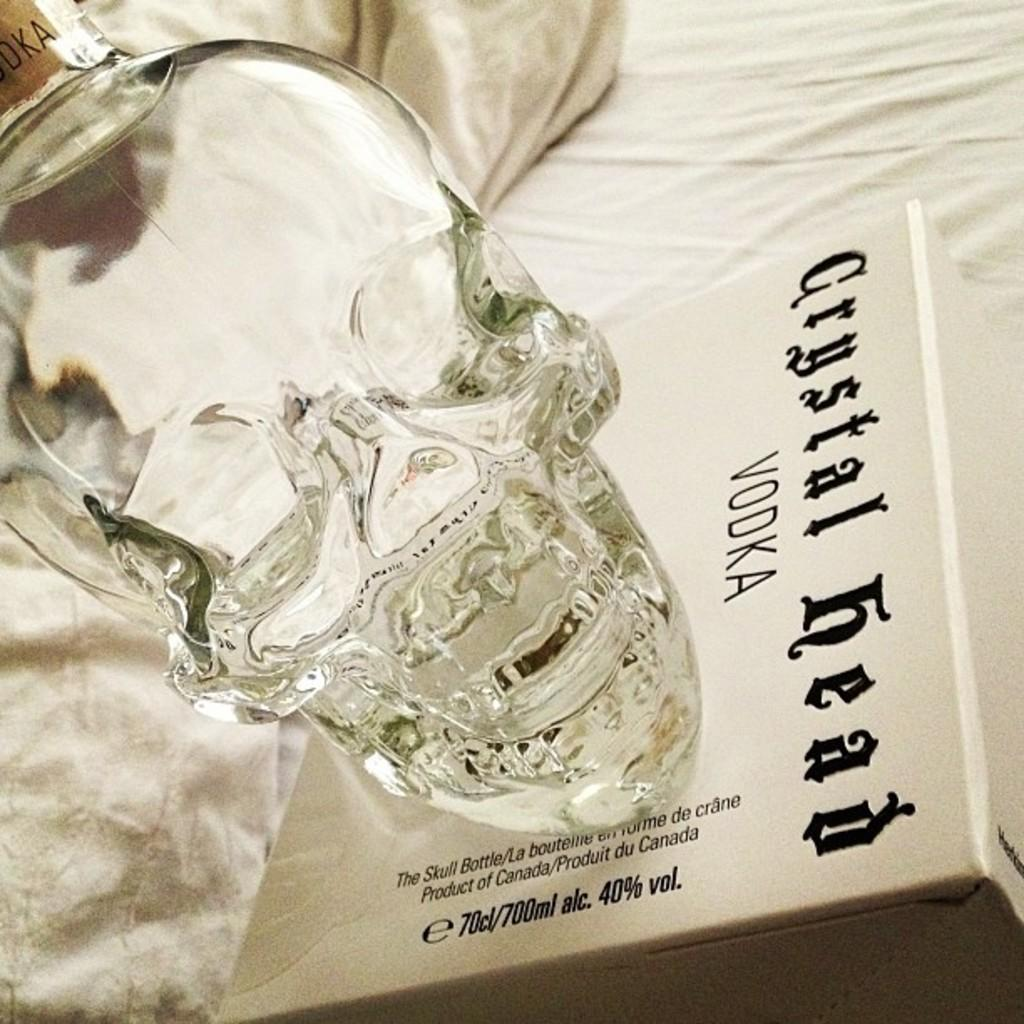<image>
Relay a brief, clear account of the picture shown. A bottle of Crystal Head vodka is shaped like a crystal head. 